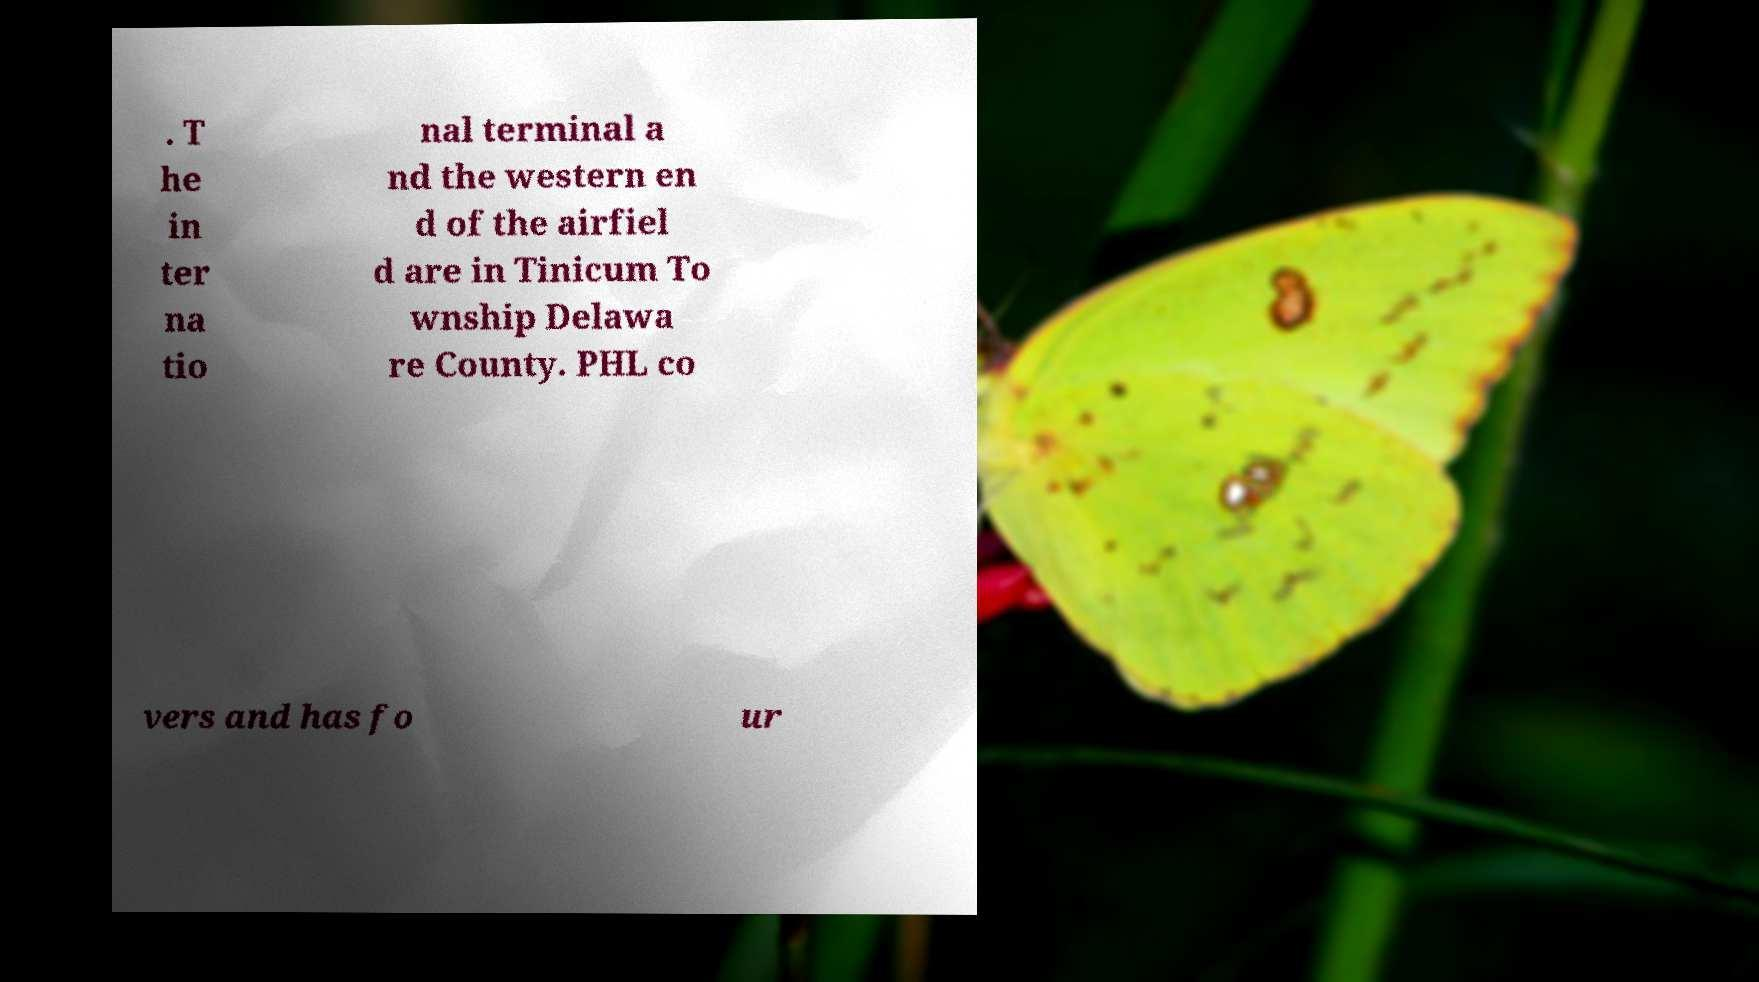Can you read and provide the text displayed in the image?This photo seems to have some interesting text. Can you extract and type it out for me? . T he in ter na tio nal terminal a nd the western en d of the airfiel d are in Tinicum To wnship Delawa re County. PHL co vers and has fo ur 